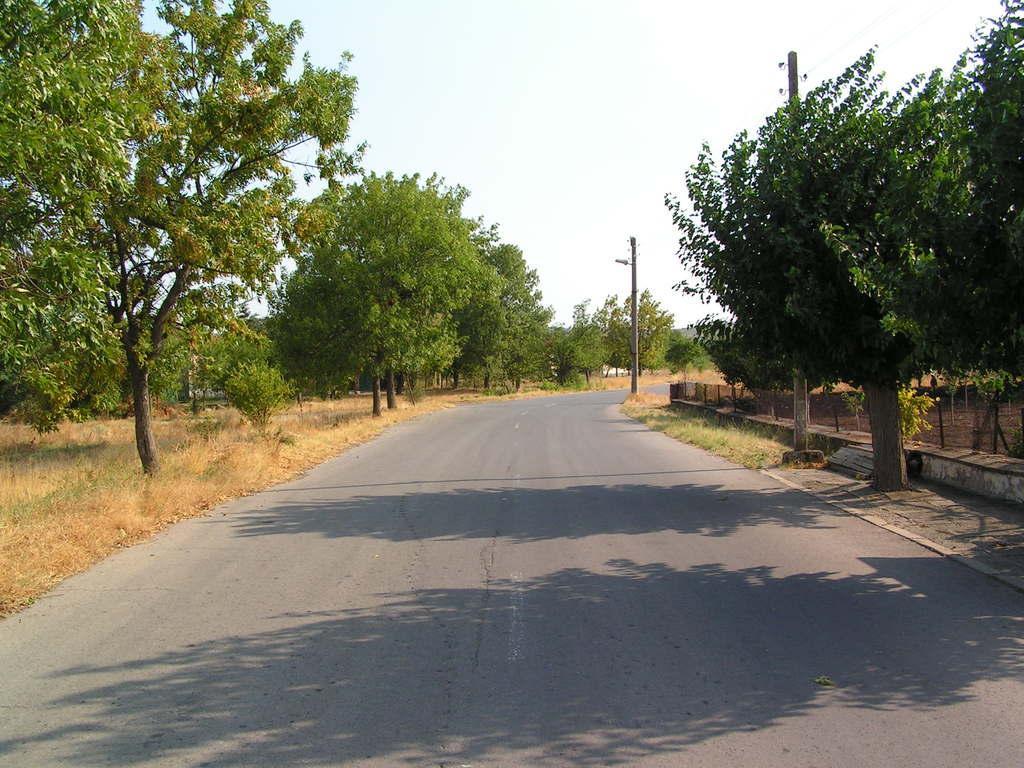How would you summarize this image in a sentence or two? In this image, we can see a road in between trees. There are poles beside the road. There is a sky at the top of the image. 